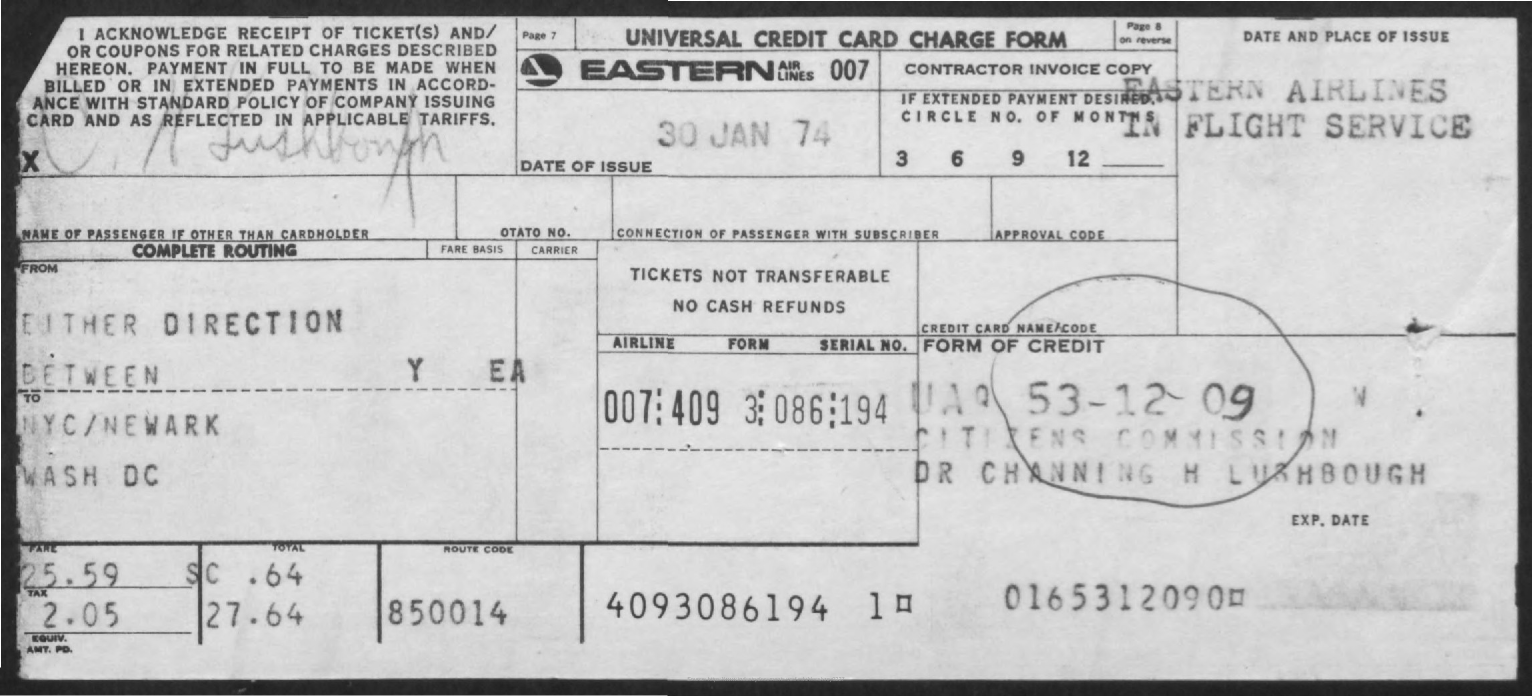Point out several critical features in this image. The fare is 25.59. The route code is 850014. The date of issue is January 30, 1974. 